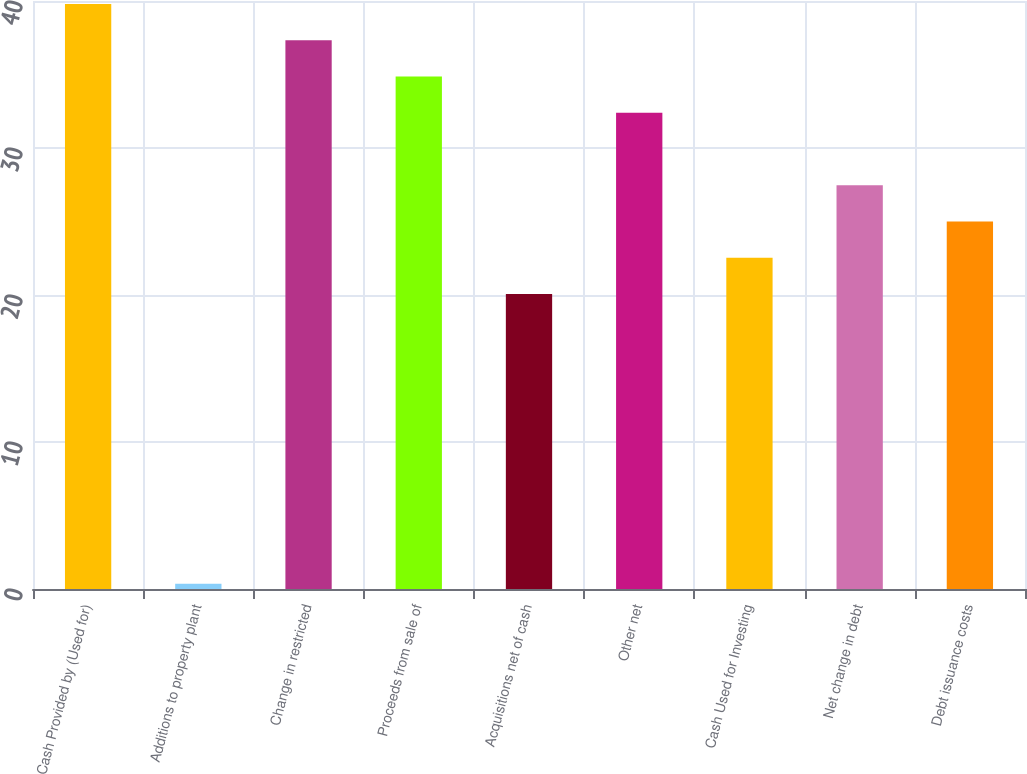Convert chart. <chart><loc_0><loc_0><loc_500><loc_500><bar_chart><fcel>Cash Provided by (Used for)<fcel>Additions to property plant<fcel>Change in restricted<fcel>Proceeds from sale of<fcel>Acquisitions net of cash<fcel>Other net<fcel>Cash Used for Investing<fcel>Net change in debt<fcel>Debt issuance costs<nl><fcel>39.8<fcel>0.35<fcel>37.33<fcel>34.86<fcel>20.07<fcel>32.39<fcel>22.54<fcel>27.46<fcel>25<nl></chart> 